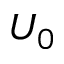Convert formula to latex. <formula><loc_0><loc_0><loc_500><loc_500>U _ { 0 }</formula> 